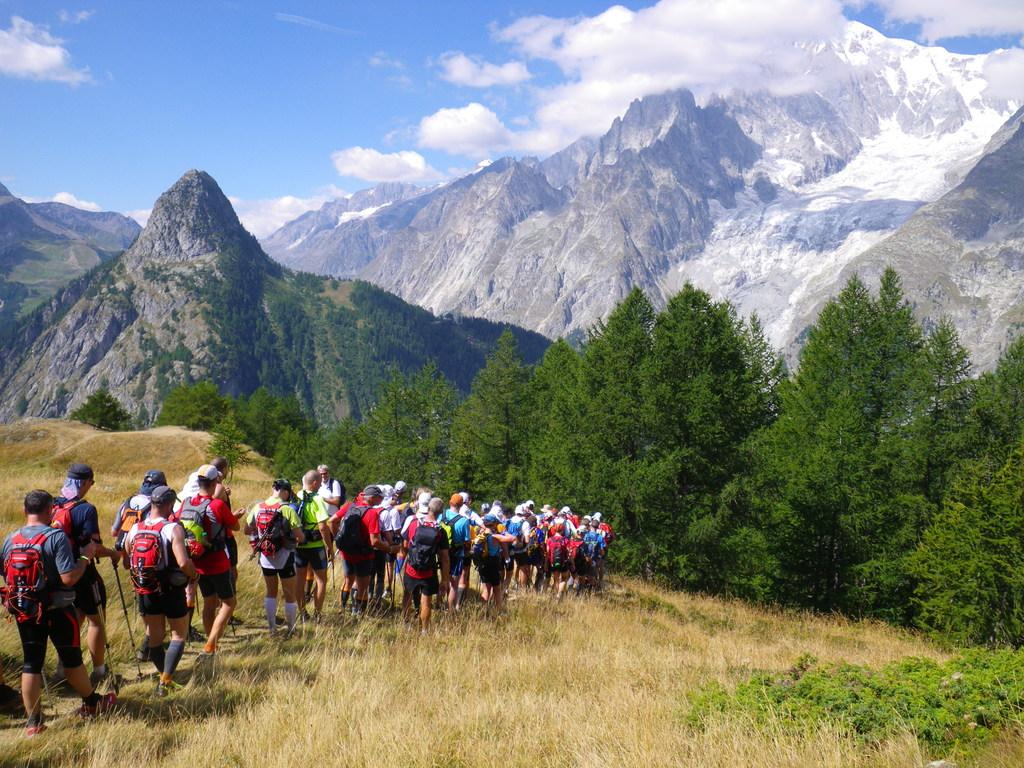What geographical feature is present in the image? There is a mountain in the image. What can be seen in the sky in the image? The sky is visible with clouds in the image. What type of vegetation is present in the image? There are trees and grass in the image. What are the people in the image doing? The people are walking, wearing caps, holding bags, and holding sticks in their hands. What type of eggs can be seen on the moon in the image? There is no moon or eggs present in the image; it features a mountain, sky, clouds, trees, grass, and a group of people walking while wearing caps, holding bags, and holding sticks in their hands. 